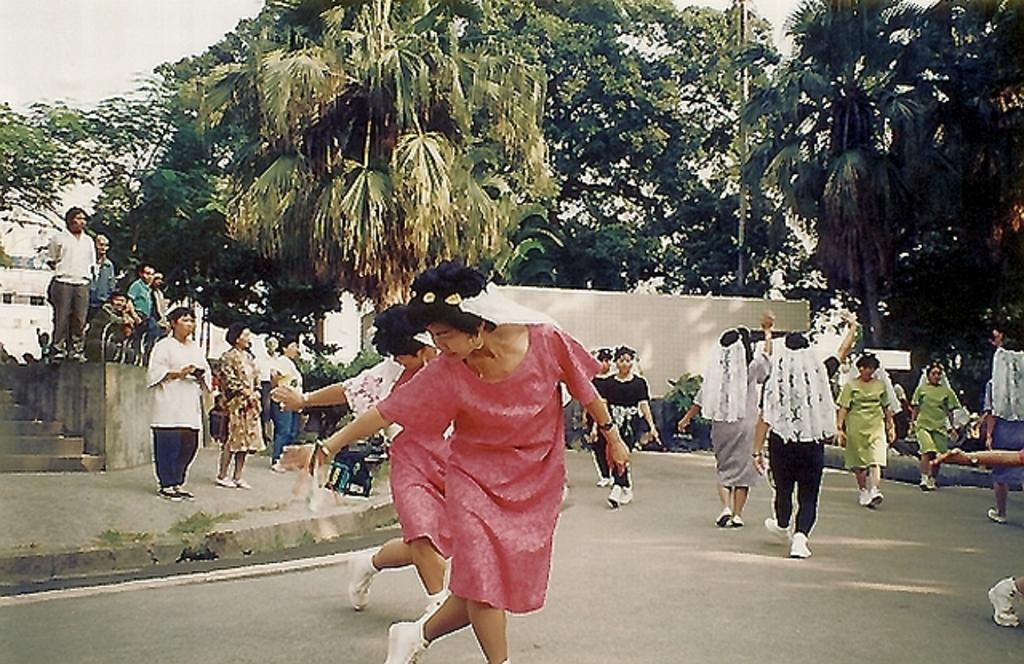What are the people in the image doing? The people in the image are walking. What type of vegetation can be seen in the image? There are green color trees in the image. Where are the stairs located in the image? The stairs are on the left side of the image. What type of jeans are the trees wearing in the image? The trees in the image are not wearing jeans, as they are not human beings or wearing any clothing. 